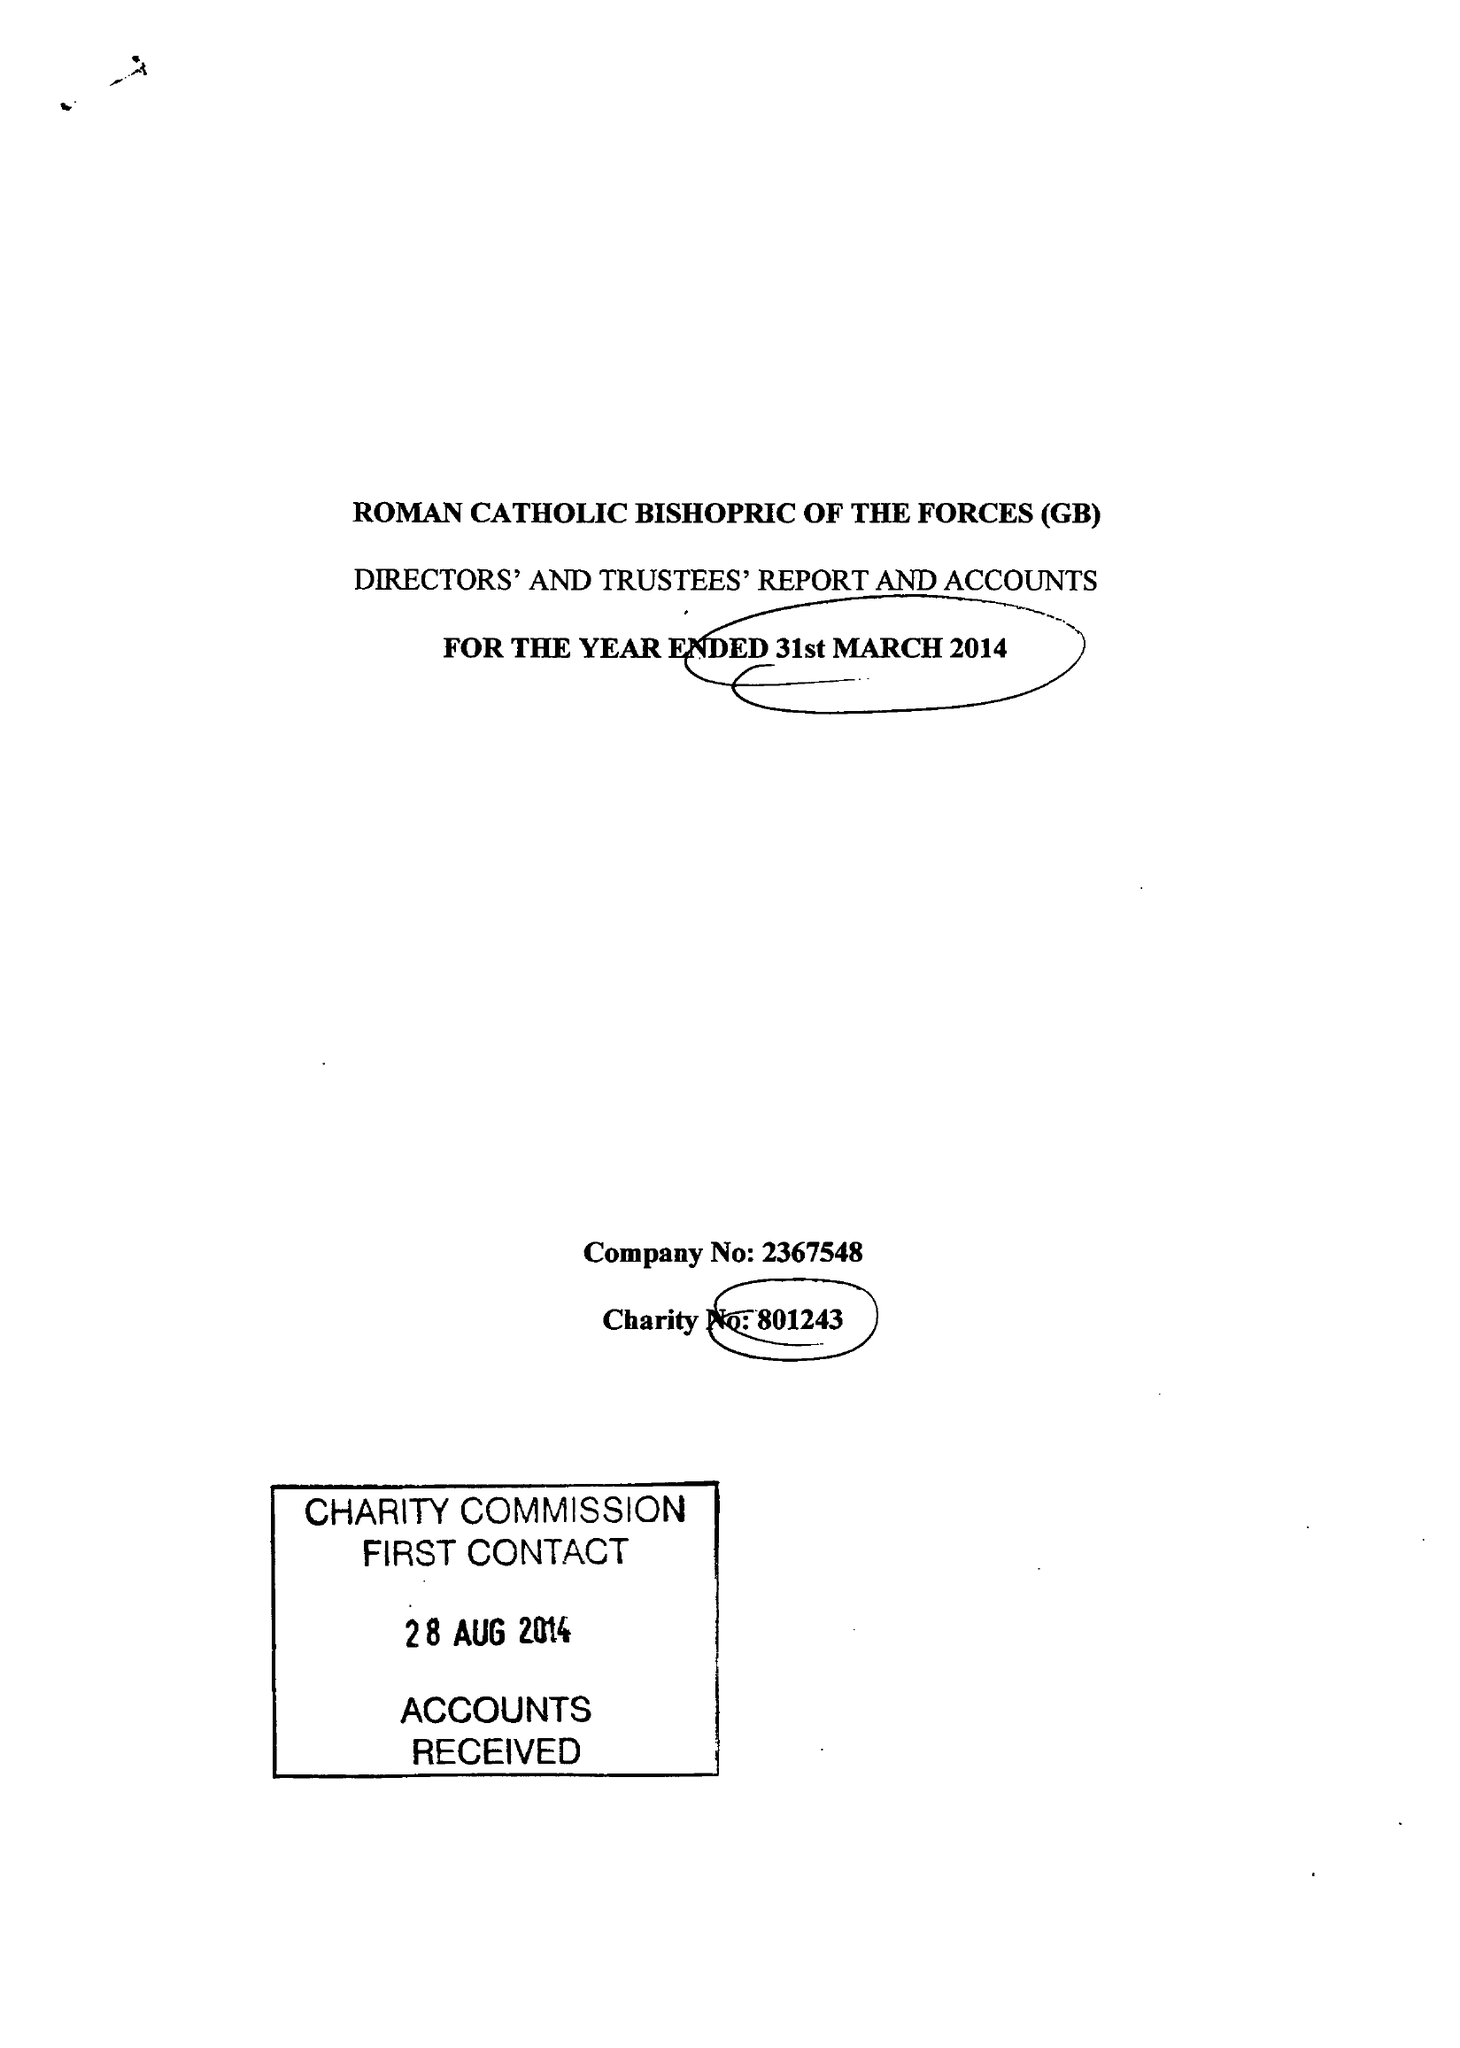What is the value for the charity_number?
Answer the question using a single word or phrase. 801243 